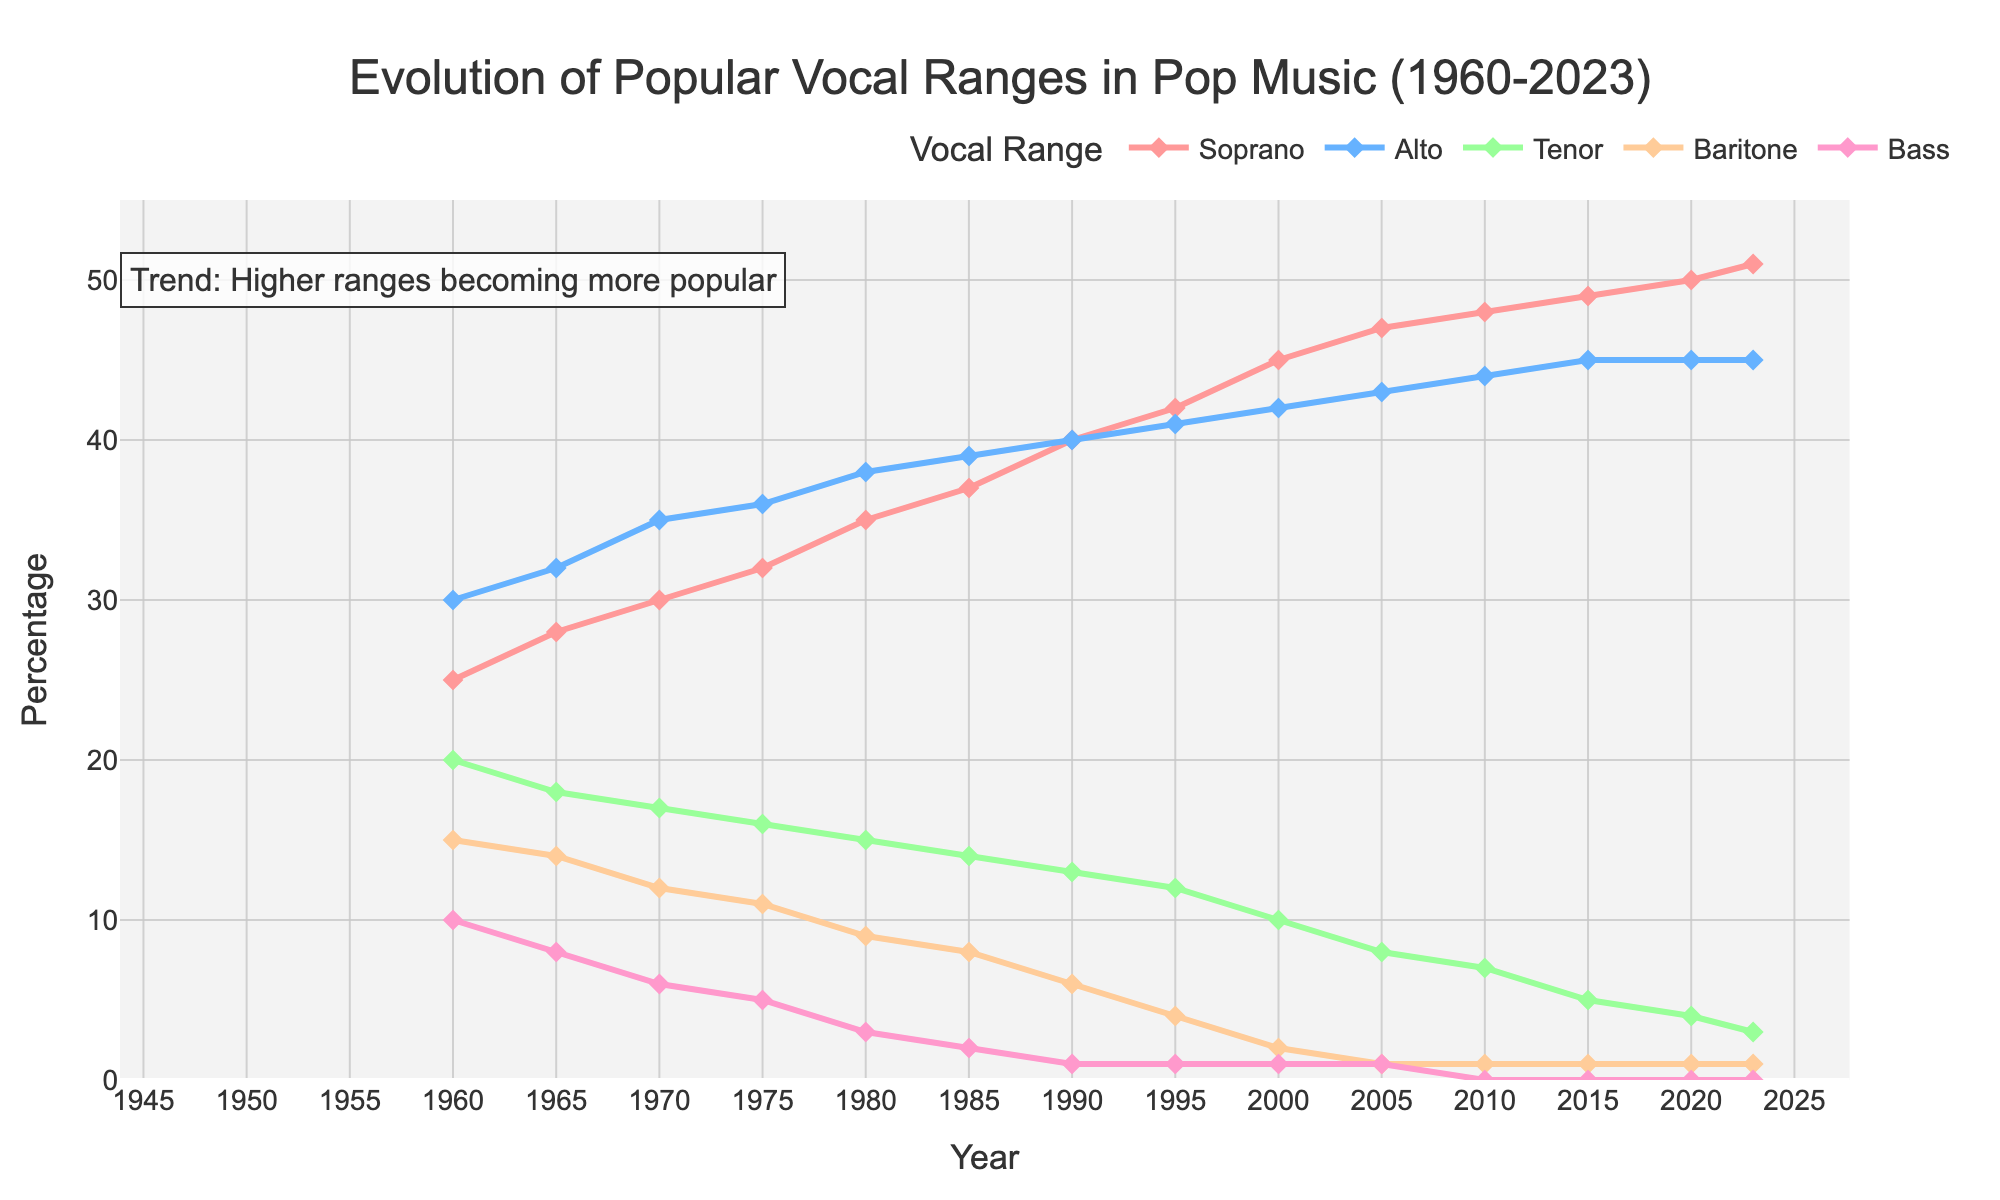What vocal range had the highest percentage in 1960? Observing the start of the figure, Soprano had a 25% share in 1960. Alto, however, had a slightly higher share at 30%, making Alto the highest in 1960.
Answer: Alto What year did Soprano surpass Alto in popularity? Observing the two traces for Soprano and Alto, Soprano surpasses Alto in 2005 where Soprano has around 47% and Alto has around 43%.
Answer: 2005 By how much did Bass decrease from 1960 to 2023? In 1960, the percentage of Bass was 10%, and by 2023, it had dropped to 0%. The decrease is calculated as 10% - 0% = 10%.
Answer: 10% Which vocal ranges have a non-zero percentage in 2023? Looking at the data points for 2023, Soprano (51%) and Alto (45%) are the only ones with non-zero percentages, while the rest have 0%.
Answer: Soprano, Alto Between 1980 and 2000, which vocal range saw the largest increase? Soprano increased from 35% to 45%, a 10% increase. Alto went from 38% to 42%, a 4% increase. Tenor dropped from 15% to 10%. Baritone and Bass also decreased. Soprano saw the largest increase.
Answer: Soprano What is the percentage difference between Baritone and Tenor in 1995? In 1995, Tenor had 12% while Baritone had 4%. The difference is 12% - 4% = 8%.
Answer: 8% Which range consistently declined from 1960 to 2023? Observing each line, Bass consistently declines from 10% in 1960 to 0% in 2023.
Answer: Bass From 2010 to 2023, by how many percentage points did Tenor decrease? Tenor dropped from 7% in 2010 to 3% in 2023, so the decrease is 7% - 3% = 4%.
Answer: 4% What is the combined percentage of Soprano and Alto in 1980? In 1980, Soprano had 35% and Alto had 38%. The combined percentage is 35% + 38% = 73%.
Answer: 73% Which vocal range has remained unchanged since 1990? Observing Baritone, it has stayed at 1% from 2000 to 2023.
Answer: Baritone 